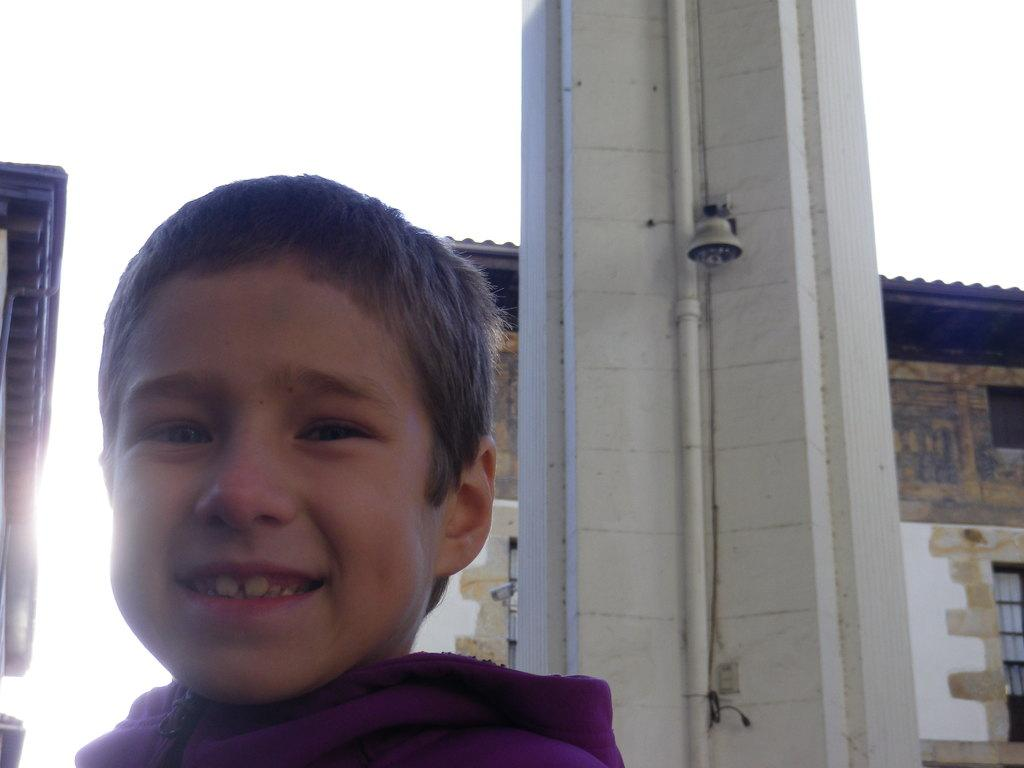Who is present in the image? There is a boy in the image. What structure can be seen in the image? There is a house in the image. What part of the natural environment is visible in the image? The sky is visible in the image. How many women are sitting on the chair in the image? There are no women or chairs present in the image. 